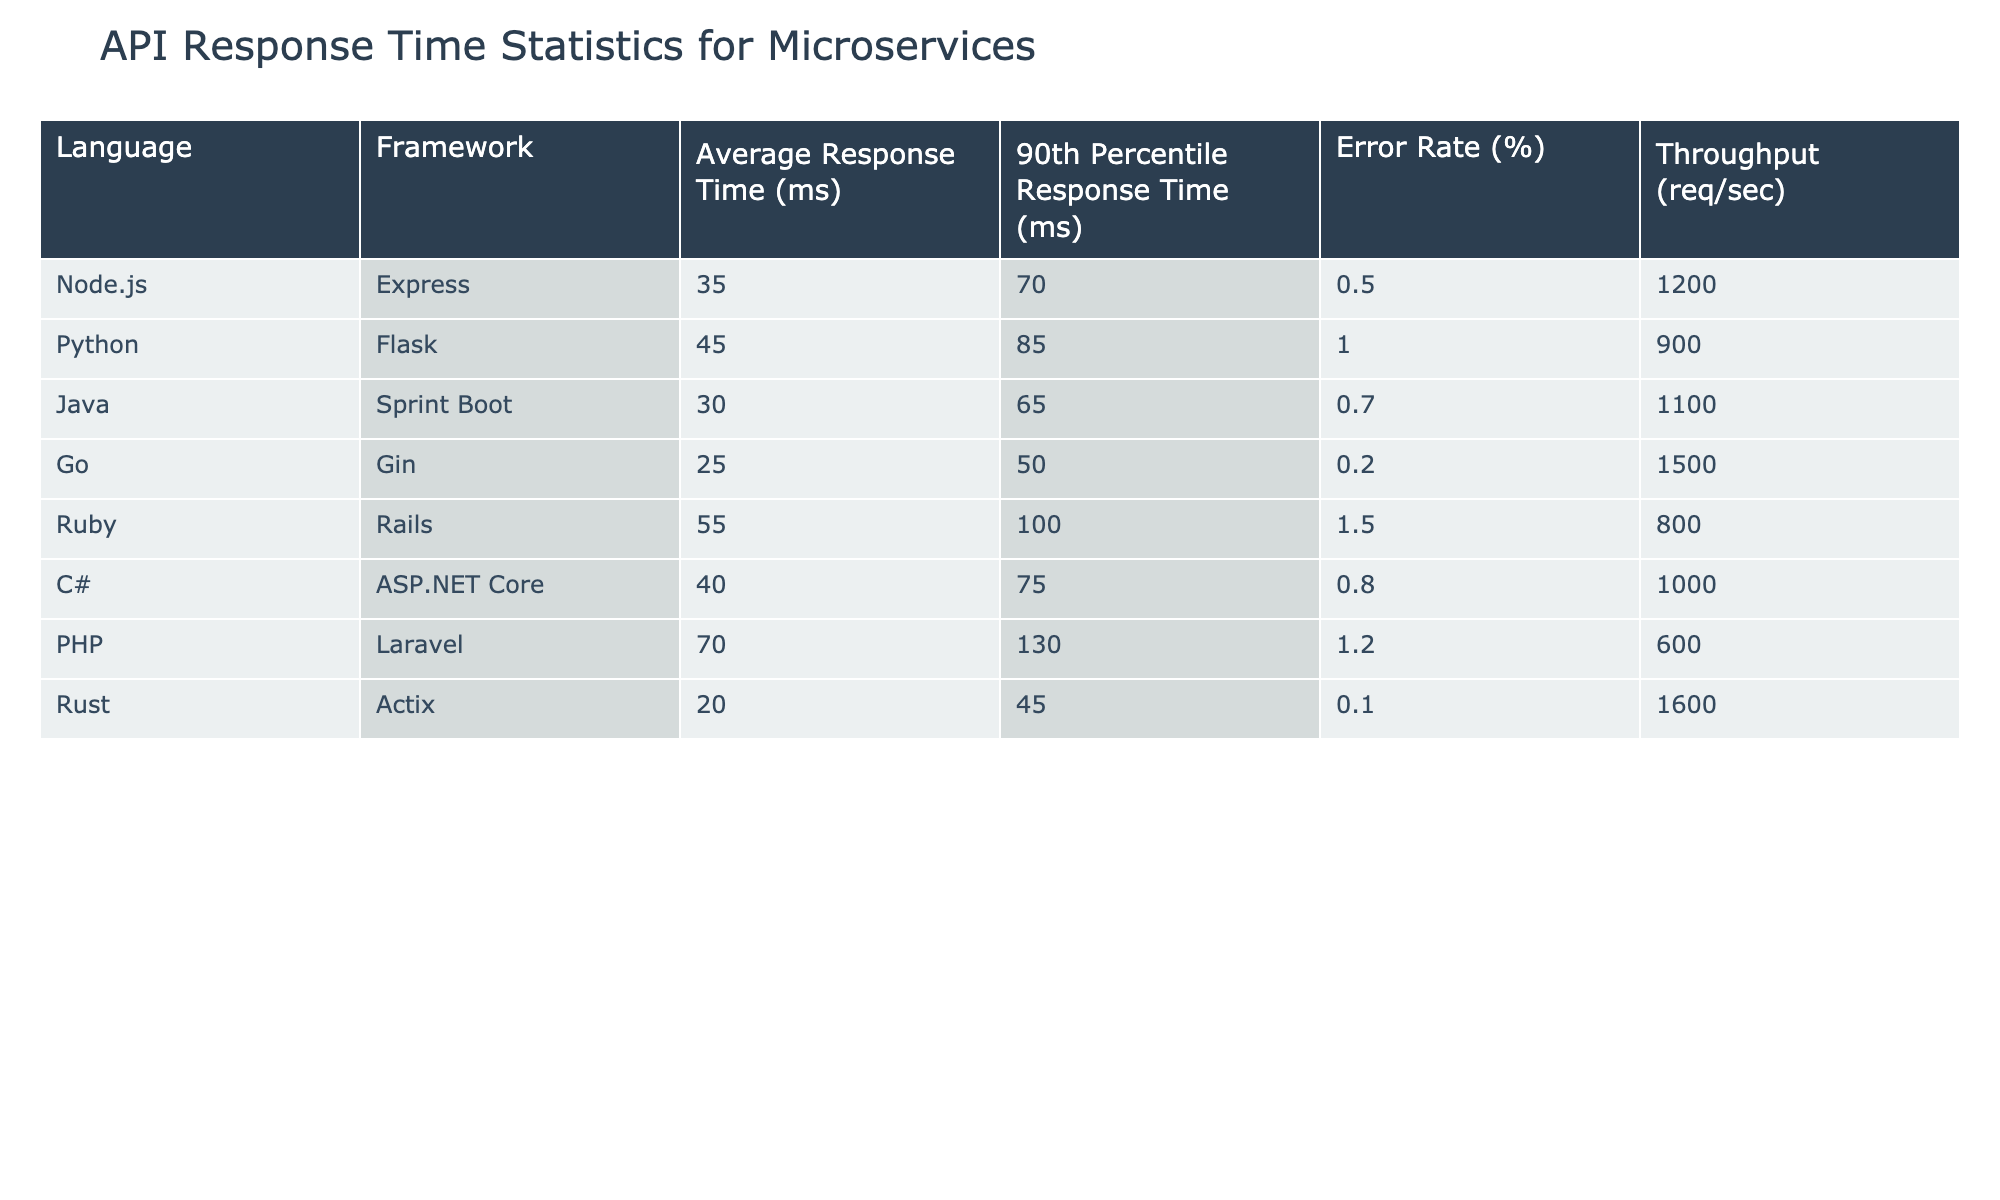What is the average response time for microservices built with Go? The table shows that the average response time for the Go framework (Gin) is listed under the 'Average Response Time (ms)' column, which is 25 ms.
Answer: 25 ms Which backend language has the highest error rate? Looking at the 'Error Rate (%)' column of the table, Ruby (Rails) has the highest error rate at 1.5%.
Answer: Ruby (Rails) What is the difference in average response time between Java and Python? The average response time for Java (Spring Boot) is 30 ms, and for Python (Flask) it is 45 ms. To find the difference, subtract the Java time from the Python time: 45 ms - 30 ms = 15 ms.
Answer: 15 ms Is the throughput of Node.js higher than that of Ruby? The throughput for Node.js (Express) is 1200 req/sec, while for Ruby (Rails) it is 800 req/sec. Since 1200 is greater than 800, the answer is yes.
Answer: Yes What is the average error rate for all the languages in the table? To find the average error rate, add all the error rates together (0.5 + 1.0 + 0.7 + 0.2 + 1.5 + 0.8 + 1.2 + 0.1) which equals 5.0%, and then divide by the number of languages (8): 5.0% / 8 = 0.625%.
Answer: 0.625% Which language has the lowest 90th percentile response time, and what is that time? The '90th Percentile Response Time (ms)' column indicates that Rust (Actix) has the lowest time at 45 ms.
Answer: Rust (Actix), 45 ms How does the throughput of C# compare to that of Go? The throughput for C# (ASP.NET Core) is 1000 req/sec, while for Go (Gin) it is 1500 req/sec. Since 1000 is less than 1500, C# has a lower throughput than Go.
Answer: C# has a lower throughput than Go What is the total throughput of all listed languages combined? To get total throughput, sum the throughput values for all languages: 1200 + 900 + 1100 + 1500 + 800 + 1000 + 600 + 1600 = 7100 req/sec.
Answer: 7100 req/sec Did any of the languages have a response time of over 50 ms? Looking through the 'Average Response Time (ms)' column, both Python (Flask) at 45 ms and Ruby (Rails) at 55 ms have average response times of 50 ms or greater, confirming that at least one language does exceed this threshold.
Answer: Yes 